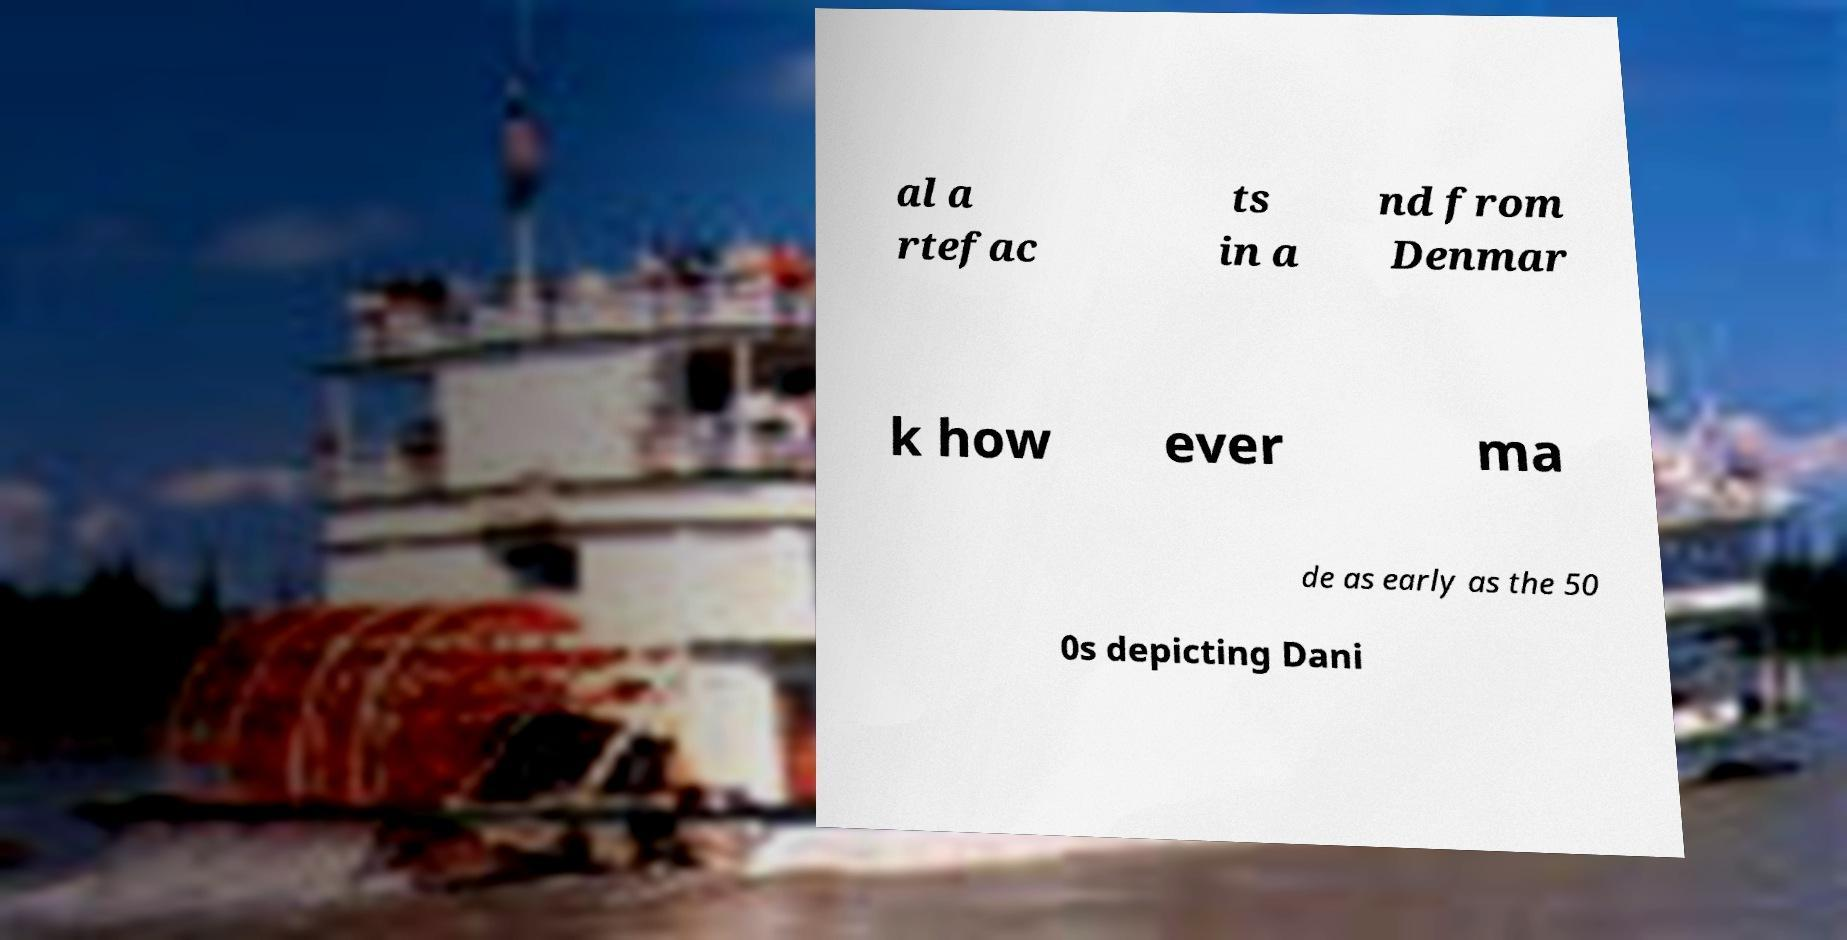Could you extract and type out the text from this image? al a rtefac ts in a nd from Denmar k how ever ma de as early as the 50 0s depicting Dani 